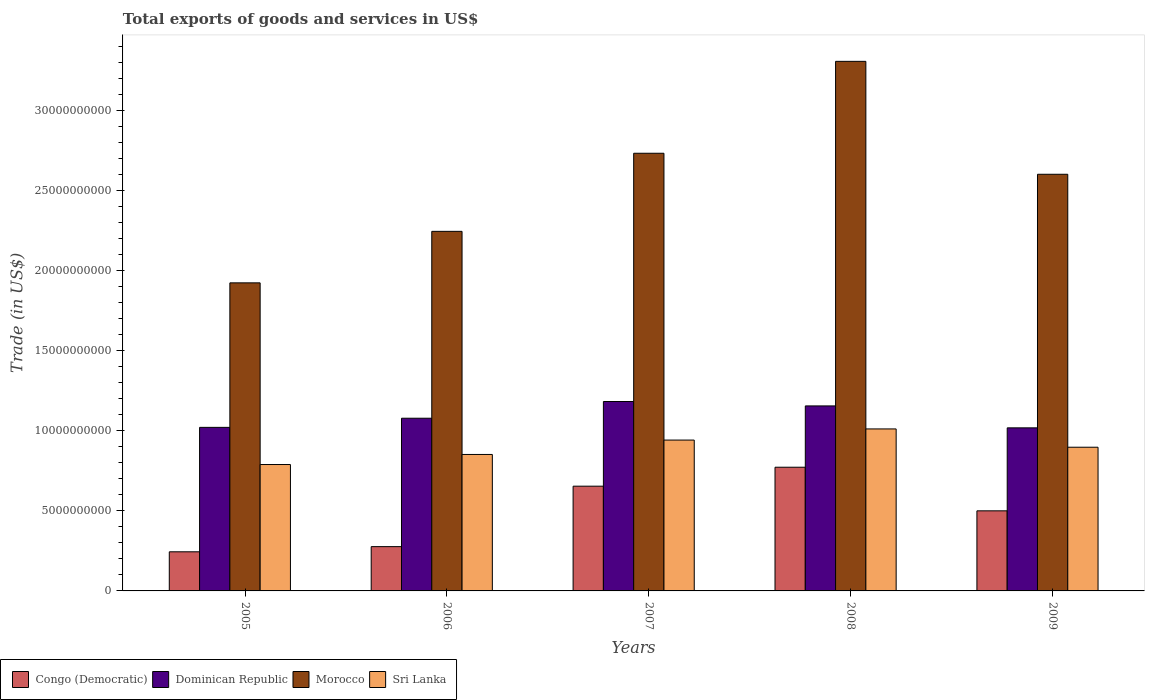Are the number of bars on each tick of the X-axis equal?
Offer a very short reply. Yes. What is the total exports of goods and services in Sri Lanka in 2009?
Offer a terse response. 8.97e+09. Across all years, what is the maximum total exports of goods and services in Dominican Republic?
Offer a very short reply. 1.18e+1. Across all years, what is the minimum total exports of goods and services in Dominican Republic?
Offer a terse response. 1.02e+1. In which year was the total exports of goods and services in Dominican Republic maximum?
Make the answer very short. 2007. What is the total total exports of goods and services in Congo (Democratic) in the graph?
Your answer should be compact. 2.45e+1. What is the difference between the total exports of goods and services in Sri Lanka in 2007 and that in 2009?
Provide a short and direct response. 4.47e+08. What is the difference between the total exports of goods and services in Sri Lanka in 2008 and the total exports of goods and services in Dominican Republic in 2007?
Your answer should be very brief. -1.71e+09. What is the average total exports of goods and services in Dominican Republic per year?
Your response must be concise. 1.09e+1. In the year 2006, what is the difference between the total exports of goods and services in Dominican Republic and total exports of goods and services in Congo (Democratic)?
Keep it short and to the point. 8.02e+09. In how many years, is the total exports of goods and services in Sri Lanka greater than 2000000000 US$?
Your answer should be compact. 5. What is the ratio of the total exports of goods and services in Morocco in 2006 to that in 2009?
Offer a very short reply. 0.86. Is the total exports of goods and services in Sri Lanka in 2005 less than that in 2007?
Your response must be concise. Yes. Is the difference between the total exports of goods and services in Dominican Republic in 2006 and 2008 greater than the difference between the total exports of goods and services in Congo (Democratic) in 2006 and 2008?
Keep it short and to the point. Yes. What is the difference between the highest and the second highest total exports of goods and services in Morocco?
Your answer should be very brief. 5.74e+09. What is the difference between the highest and the lowest total exports of goods and services in Sri Lanka?
Provide a short and direct response. 2.22e+09. Is it the case that in every year, the sum of the total exports of goods and services in Morocco and total exports of goods and services in Sri Lanka is greater than the sum of total exports of goods and services in Dominican Republic and total exports of goods and services in Congo (Democratic)?
Make the answer very short. Yes. What does the 2nd bar from the left in 2007 represents?
Offer a very short reply. Dominican Republic. What does the 1st bar from the right in 2008 represents?
Provide a short and direct response. Sri Lanka. What is the difference between two consecutive major ticks on the Y-axis?
Ensure brevity in your answer.  5.00e+09. Are the values on the major ticks of Y-axis written in scientific E-notation?
Provide a short and direct response. No. Does the graph contain any zero values?
Make the answer very short. No. Where does the legend appear in the graph?
Provide a succinct answer. Bottom left. How many legend labels are there?
Your response must be concise. 4. How are the legend labels stacked?
Provide a short and direct response. Horizontal. What is the title of the graph?
Provide a short and direct response. Total exports of goods and services in US$. Does "Micronesia" appear as one of the legend labels in the graph?
Your response must be concise. No. What is the label or title of the Y-axis?
Ensure brevity in your answer.  Trade (in US$). What is the Trade (in US$) of Congo (Democratic) in 2005?
Give a very brief answer. 2.44e+09. What is the Trade (in US$) in Dominican Republic in 2005?
Keep it short and to the point. 1.02e+1. What is the Trade (in US$) in Morocco in 2005?
Give a very brief answer. 1.92e+1. What is the Trade (in US$) in Sri Lanka in 2005?
Make the answer very short. 7.89e+09. What is the Trade (in US$) in Congo (Democratic) in 2006?
Keep it short and to the point. 2.77e+09. What is the Trade (in US$) of Dominican Republic in 2006?
Offer a very short reply. 1.08e+1. What is the Trade (in US$) of Morocco in 2006?
Your answer should be very brief. 2.24e+1. What is the Trade (in US$) of Sri Lanka in 2006?
Your response must be concise. 8.52e+09. What is the Trade (in US$) in Congo (Democratic) in 2007?
Make the answer very short. 6.54e+09. What is the Trade (in US$) of Dominican Republic in 2007?
Your response must be concise. 1.18e+1. What is the Trade (in US$) in Morocco in 2007?
Provide a short and direct response. 2.73e+1. What is the Trade (in US$) in Sri Lanka in 2007?
Make the answer very short. 9.42e+09. What is the Trade (in US$) of Congo (Democratic) in 2008?
Ensure brevity in your answer.  7.72e+09. What is the Trade (in US$) in Dominican Republic in 2008?
Your answer should be compact. 1.16e+1. What is the Trade (in US$) in Morocco in 2008?
Give a very brief answer. 3.31e+1. What is the Trade (in US$) of Sri Lanka in 2008?
Offer a terse response. 1.01e+1. What is the Trade (in US$) in Congo (Democratic) in 2009?
Ensure brevity in your answer.  5.00e+09. What is the Trade (in US$) in Dominican Republic in 2009?
Make the answer very short. 1.02e+1. What is the Trade (in US$) in Morocco in 2009?
Provide a succinct answer. 2.60e+1. What is the Trade (in US$) in Sri Lanka in 2009?
Provide a succinct answer. 8.97e+09. Across all years, what is the maximum Trade (in US$) in Congo (Democratic)?
Ensure brevity in your answer.  7.72e+09. Across all years, what is the maximum Trade (in US$) of Dominican Republic?
Provide a succinct answer. 1.18e+1. Across all years, what is the maximum Trade (in US$) of Morocco?
Your answer should be very brief. 3.31e+1. Across all years, what is the maximum Trade (in US$) of Sri Lanka?
Your answer should be very brief. 1.01e+1. Across all years, what is the minimum Trade (in US$) of Congo (Democratic)?
Your answer should be compact. 2.44e+09. Across all years, what is the minimum Trade (in US$) in Dominican Republic?
Make the answer very short. 1.02e+1. Across all years, what is the minimum Trade (in US$) in Morocco?
Your answer should be compact. 1.92e+1. Across all years, what is the minimum Trade (in US$) of Sri Lanka?
Offer a terse response. 7.89e+09. What is the total Trade (in US$) of Congo (Democratic) in the graph?
Provide a succinct answer. 2.45e+1. What is the total Trade (in US$) of Dominican Republic in the graph?
Your response must be concise. 5.46e+1. What is the total Trade (in US$) of Morocco in the graph?
Your response must be concise. 1.28e+11. What is the total Trade (in US$) in Sri Lanka in the graph?
Keep it short and to the point. 4.49e+1. What is the difference between the Trade (in US$) of Congo (Democratic) in 2005 and that in 2006?
Your answer should be compact. -3.23e+08. What is the difference between the Trade (in US$) in Dominican Republic in 2005 and that in 2006?
Your response must be concise. -5.71e+08. What is the difference between the Trade (in US$) in Morocco in 2005 and that in 2006?
Keep it short and to the point. -3.22e+09. What is the difference between the Trade (in US$) in Sri Lanka in 2005 and that in 2006?
Offer a terse response. -6.28e+08. What is the difference between the Trade (in US$) in Congo (Democratic) in 2005 and that in 2007?
Keep it short and to the point. -4.10e+09. What is the difference between the Trade (in US$) of Dominican Republic in 2005 and that in 2007?
Offer a very short reply. -1.61e+09. What is the difference between the Trade (in US$) in Morocco in 2005 and that in 2007?
Provide a succinct answer. -8.09e+09. What is the difference between the Trade (in US$) in Sri Lanka in 2005 and that in 2007?
Make the answer very short. -1.53e+09. What is the difference between the Trade (in US$) of Congo (Democratic) in 2005 and that in 2008?
Your response must be concise. -5.28e+09. What is the difference between the Trade (in US$) of Dominican Republic in 2005 and that in 2008?
Make the answer very short. -1.34e+09. What is the difference between the Trade (in US$) of Morocco in 2005 and that in 2008?
Offer a terse response. -1.38e+1. What is the difference between the Trade (in US$) of Sri Lanka in 2005 and that in 2008?
Keep it short and to the point. -2.22e+09. What is the difference between the Trade (in US$) of Congo (Democratic) in 2005 and that in 2009?
Your response must be concise. -2.56e+09. What is the difference between the Trade (in US$) in Dominican Republic in 2005 and that in 2009?
Make the answer very short. 2.99e+07. What is the difference between the Trade (in US$) in Morocco in 2005 and that in 2009?
Make the answer very short. -6.78e+09. What is the difference between the Trade (in US$) of Sri Lanka in 2005 and that in 2009?
Keep it short and to the point. -1.08e+09. What is the difference between the Trade (in US$) in Congo (Democratic) in 2006 and that in 2007?
Provide a succinct answer. -3.77e+09. What is the difference between the Trade (in US$) of Dominican Republic in 2006 and that in 2007?
Your response must be concise. -1.04e+09. What is the difference between the Trade (in US$) of Morocco in 2006 and that in 2007?
Provide a short and direct response. -4.88e+09. What is the difference between the Trade (in US$) of Sri Lanka in 2006 and that in 2007?
Your answer should be compact. -8.98e+08. What is the difference between the Trade (in US$) in Congo (Democratic) in 2006 and that in 2008?
Make the answer very short. -4.96e+09. What is the difference between the Trade (in US$) in Dominican Republic in 2006 and that in 2008?
Your answer should be very brief. -7.68e+08. What is the difference between the Trade (in US$) of Morocco in 2006 and that in 2008?
Offer a very short reply. -1.06e+1. What is the difference between the Trade (in US$) in Sri Lanka in 2006 and that in 2008?
Your answer should be very brief. -1.59e+09. What is the difference between the Trade (in US$) in Congo (Democratic) in 2006 and that in 2009?
Provide a short and direct response. -2.24e+09. What is the difference between the Trade (in US$) of Dominican Republic in 2006 and that in 2009?
Provide a succinct answer. 6.01e+08. What is the difference between the Trade (in US$) in Morocco in 2006 and that in 2009?
Your answer should be compact. -3.56e+09. What is the difference between the Trade (in US$) of Sri Lanka in 2006 and that in 2009?
Give a very brief answer. -4.52e+08. What is the difference between the Trade (in US$) in Congo (Democratic) in 2007 and that in 2008?
Ensure brevity in your answer.  -1.18e+09. What is the difference between the Trade (in US$) of Dominican Republic in 2007 and that in 2008?
Your answer should be very brief. 2.75e+08. What is the difference between the Trade (in US$) in Morocco in 2007 and that in 2008?
Keep it short and to the point. -5.74e+09. What is the difference between the Trade (in US$) of Sri Lanka in 2007 and that in 2008?
Offer a terse response. -6.95e+08. What is the difference between the Trade (in US$) of Congo (Democratic) in 2007 and that in 2009?
Keep it short and to the point. 1.54e+09. What is the difference between the Trade (in US$) of Dominican Republic in 2007 and that in 2009?
Give a very brief answer. 1.64e+09. What is the difference between the Trade (in US$) in Morocco in 2007 and that in 2009?
Your response must be concise. 1.31e+09. What is the difference between the Trade (in US$) of Sri Lanka in 2007 and that in 2009?
Make the answer very short. 4.47e+08. What is the difference between the Trade (in US$) in Congo (Democratic) in 2008 and that in 2009?
Ensure brevity in your answer.  2.72e+09. What is the difference between the Trade (in US$) of Dominican Republic in 2008 and that in 2009?
Your answer should be compact. 1.37e+09. What is the difference between the Trade (in US$) in Morocco in 2008 and that in 2009?
Your response must be concise. 7.05e+09. What is the difference between the Trade (in US$) of Sri Lanka in 2008 and that in 2009?
Your answer should be very brief. 1.14e+09. What is the difference between the Trade (in US$) in Congo (Democratic) in 2005 and the Trade (in US$) in Dominican Republic in 2006?
Your response must be concise. -8.34e+09. What is the difference between the Trade (in US$) in Congo (Democratic) in 2005 and the Trade (in US$) in Morocco in 2006?
Make the answer very short. -2.00e+1. What is the difference between the Trade (in US$) in Congo (Democratic) in 2005 and the Trade (in US$) in Sri Lanka in 2006?
Provide a short and direct response. -6.08e+09. What is the difference between the Trade (in US$) of Dominican Republic in 2005 and the Trade (in US$) of Morocco in 2006?
Give a very brief answer. -1.22e+1. What is the difference between the Trade (in US$) in Dominican Republic in 2005 and the Trade (in US$) in Sri Lanka in 2006?
Provide a short and direct response. 1.69e+09. What is the difference between the Trade (in US$) in Morocco in 2005 and the Trade (in US$) in Sri Lanka in 2006?
Provide a short and direct response. 1.07e+1. What is the difference between the Trade (in US$) of Congo (Democratic) in 2005 and the Trade (in US$) of Dominican Republic in 2007?
Your answer should be very brief. -9.38e+09. What is the difference between the Trade (in US$) in Congo (Democratic) in 2005 and the Trade (in US$) in Morocco in 2007?
Make the answer very short. -2.49e+1. What is the difference between the Trade (in US$) of Congo (Democratic) in 2005 and the Trade (in US$) of Sri Lanka in 2007?
Your answer should be very brief. -6.98e+09. What is the difference between the Trade (in US$) of Dominican Republic in 2005 and the Trade (in US$) of Morocco in 2007?
Provide a succinct answer. -1.71e+1. What is the difference between the Trade (in US$) in Dominican Republic in 2005 and the Trade (in US$) in Sri Lanka in 2007?
Ensure brevity in your answer.  7.93e+08. What is the difference between the Trade (in US$) of Morocco in 2005 and the Trade (in US$) of Sri Lanka in 2007?
Provide a succinct answer. 9.82e+09. What is the difference between the Trade (in US$) in Congo (Democratic) in 2005 and the Trade (in US$) in Dominican Republic in 2008?
Your answer should be compact. -9.11e+09. What is the difference between the Trade (in US$) of Congo (Democratic) in 2005 and the Trade (in US$) of Morocco in 2008?
Your response must be concise. -3.06e+1. What is the difference between the Trade (in US$) in Congo (Democratic) in 2005 and the Trade (in US$) in Sri Lanka in 2008?
Keep it short and to the point. -7.67e+09. What is the difference between the Trade (in US$) of Dominican Republic in 2005 and the Trade (in US$) of Morocco in 2008?
Ensure brevity in your answer.  -2.29e+1. What is the difference between the Trade (in US$) of Dominican Republic in 2005 and the Trade (in US$) of Sri Lanka in 2008?
Make the answer very short. 9.77e+07. What is the difference between the Trade (in US$) of Morocco in 2005 and the Trade (in US$) of Sri Lanka in 2008?
Make the answer very short. 9.12e+09. What is the difference between the Trade (in US$) in Congo (Democratic) in 2005 and the Trade (in US$) in Dominican Republic in 2009?
Your answer should be very brief. -7.74e+09. What is the difference between the Trade (in US$) in Congo (Democratic) in 2005 and the Trade (in US$) in Morocco in 2009?
Give a very brief answer. -2.36e+1. What is the difference between the Trade (in US$) of Congo (Democratic) in 2005 and the Trade (in US$) of Sri Lanka in 2009?
Give a very brief answer. -6.53e+09. What is the difference between the Trade (in US$) in Dominican Republic in 2005 and the Trade (in US$) in Morocco in 2009?
Offer a very short reply. -1.58e+1. What is the difference between the Trade (in US$) in Dominican Republic in 2005 and the Trade (in US$) in Sri Lanka in 2009?
Give a very brief answer. 1.24e+09. What is the difference between the Trade (in US$) of Morocco in 2005 and the Trade (in US$) of Sri Lanka in 2009?
Offer a very short reply. 1.03e+1. What is the difference between the Trade (in US$) of Congo (Democratic) in 2006 and the Trade (in US$) of Dominican Republic in 2007?
Ensure brevity in your answer.  -9.06e+09. What is the difference between the Trade (in US$) in Congo (Democratic) in 2006 and the Trade (in US$) in Morocco in 2007?
Offer a very short reply. -2.46e+1. What is the difference between the Trade (in US$) of Congo (Democratic) in 2006 and the Trade (in US$) of Sri Lanka in 2007?
Offer a terse response. -6.65e+09. What is the difference between the Trade (in US$) in Dominican Republic in 2006 and the Trade (in US$) in Morocco in 2007?
Your answer should be very brief. -1.65e+1. What is the difference between the Trade (in US$) in Dominican Republic in 2006 and the Trade (in US$) in Sri Lanka in 2007?
Provide a short and direct response. 1.36e+09. What is the difference between the Trade (in US$) of Morocco in 2006 and the Trade (in US$) of Sri Lanka in 2007?
Provide a short and direct response. 1.30e+1. What is the difference between the Trade (in US$) of Congo (Democratic) in 2006 and the Trade (in US$) of Dominican Republic in 2008?
Offer a terse response. -8.79e+09. What is the difference between the Trade (in US$) of Congo (Democratic) in 2006 and the Trade (in US$) of Morocco in 2008?
Give a very brief answer. -3.03e+1. What is the difference between the Trade (in US$) of Congo (Democratic) in 2006 and the Trade (in US$) of Sri Lanka in 2008?
Provide a succinct answer. -7.35e+09. What is the difference between the Trade (in US$) of Dominican Republic in 2006 and the Trade (in US$) of Morocco in 2008?
Offer a terse response. -2.23e+1. What is the difference between the Trade (in US$) of Dominican Republic in 2006 and the Trade (in US$) of Sri Lanka in 2008?
Your answer should be very brief. 6.69e+08. What is the difference between the Trade (in US$) of Morocco in 2006 and the Trade (in US$) of Sri Lanka in 2008?
Ensure brevity in your answer.  1.23e+1. What is the difference between the Trade (in US$) in Congo (Democratic) in 2006 and the Trade (in US$) in Dominican Republic in 2009?
Ensure brevity in your answer.  -7.42e+09. What is the difference between the Trade (in US$) of Congo (Democratic) in 2006 and the Trade (in US$) of Morocco in 2009?
Give a very brief answer. -2.32e+1. What is the difference between the Trade (in US$) of Congo (Democratic) in 2006 and the Trade (in US$) of Sri Lanka in 2009?
Make the answer very short. -6.21e+09. What is the difference between the Trade (in US$) in Dominican Republic in 2006 and the Trade (in US$) in Morocco in 2009?
Offer a very short reply. -1.52e+1. What is the difference between the Trade (in US$) in Dominican Republic in 2006 and the Trade (in US$) in Sri Lanka in 2009?
Offer a terse response. 1.81e+09. What is the difference between the Trade (in US$) of Morocco in 2006 and the Trade (in US$) of Sri Lanka in 2009?
Your answer should be compact. 1.35e+1. What is the difference between the Trade (in US$) in Congo (Democratic) in 2007 and the Trade (in US$) in Dominican Republic in 2008?
Offer a terse response. -5.01e+09. What is the difference between the Trade (in US$) of Congo (Democratic) in 2007 and the Trade (in US$) of Morocco in 2008?
Offer a terse response. -2.65e+1. What is the difference between the Trade (in US$) in Congo (Democratic) in 2007 and the Trade (in US$) in Sri Lanka in 2008?
Offer a very short reply. -3.57e+09. What is the difference between the Trade (in US$) of Dominican Republic in 2007 and the Trade (in US$) of Morocco in 2008?
Provide a short and direct response. -2.12e+1. What is the difference between the Trade (in US$) of Dominican Republic in 2007 and the Trade (in US$) of Sri Lanka in 2008?
Offer a very short reply. 1.71e+09. What is the difference between the Trade (in US$) in Morocco in 2007 and the Trade (in US$) in Sri Lanka in 2008?
Ensure brevity in your answer.  1.72e+1. What is the difference between the Trade (in US$) in Congo (Democratic) in 2007 and the Trade (in US$) in Dominican Republic in 2009?
Your response must be concise. -3.64e+09. What is the difference between the Trade (in US$) of Congo (Democratic) in 2007 and the Trade (in US$) of Morocco in 2009?
Your answer should be very brief. -1.95e+1. What is the difference between the Trade (in US$) of Congo (Democratic) in 2007 and the Trade (in US$) of Sri Lanka in 2009?
Offer a very short reply. -2.43e+09. What is the difference between the Trade (in US$) of Dominican Republic in 2007 and the Trade (in US$) of Morocco in 2009?
Your response must be concise. -1.42e+1. What is the difference between the Trade (in US$) in Dominican Republic in 2007 and the Trade (in US$) in Sri Lanka in 2009?
Your answer should be very brief. 2.85e+09. What is the difference between the Trade (in US$) in Morocco in 2007 and the Trade (in US$) in Sri Lanka in 2009?
Keep it short and to the point. 1.84e+1. What is the difference between the Trade (in US$) of Congo (Democratic) in 2008 and the Trade (in US$) of Dominican Republic in 2009?
Ensure brevity in your answer.  -2.46e+09. What is the difference between the Trade (in US$) of Congo (Democratic) in 2008 and the Trade (in US$) of Morocco in 2009?
Your response must be concise. -1.83e+1. What is the difference between the Trade (in US$) in Congo (Democratic) in 2008 and the Trade (in US$) in Sri Lanka in 2009?
Keep it short and to the point. -1.25e+09. What is the difference between the Trade (in US$) of Dominican Republic in 2008 and the Trade (in US$) of Morocco in 2009?
Keep it short and to the point. -1.45e+1. What is the difference between the Trade (in US$) in Dominican Republic in 2008 and the Trade (in US$) in Sri Lanka in 2009?
Ensure brevity in your answer.  2.58e+09. What is the difference between the Trade (in US$) in Morocco in 2008 and the Trade (in US$) in Sri Lanka in 2009?
Your response must be concise. 2.41e+1. What is the average Trade (in US$) in Congo (Democratic) per year?
Give a very brief answer. 4.89e+09. What is the average Trade (in US$) of Dominican Republic per year?
Your answer should be compact. 1.09e+1. What is the average Trade (in US$) of Morocco per year?
Your response must be concise. 2.56e+1. What is the average Trade (in US$) of Sri Lanka per year?
Provide a short and direct response. 8.98e+09. In the year 2005, what is the difference between the Trade (in US$) of Congo (Democratic) and Trade (in US$) of Dominican Republic?
Your response must be concise. -7.77e+09. In the year 2005, what is the difference between the Trade (in US$) in Congo (Democratic) and Trade (in US$) in Morocco?
Your answer should be very brief. -1.68e+1. In the year 2005, what is the difference between the Trade (in US$) in Congo (Democratic) and Trade (in US$) in Sri Lanka?
Keep it short and to the point. -5.45e+09. In the year 2005, what is the difference between the Trade (in US$) of Dominican Republic and Trade (in US$) of Morocco?
Your response must be concise. -9.02e+09. In the year 2005, what is the difference between the Trade (in US$) of Dominican Republic and Trade (in US$) of Sri Lanka?
Keep it short and to the point. 2.32e+09. In the year 2005, what is the difference between the Trade (in US$) in Morocco and Trade (in US$) in Sri Lanka?
Your response must be concise. 1.13e+1. In the year 2006, what is the difference between the Trade (in US$) of Congo (Democratic) and Trade (in US$) of Dominican Republic?
Offer a very short reply. -8.02e+09. In the year 2006, what is the difference between the Trade (in US$) in Congo (Democratic) and Trade (in US$) in Morocco?
Ensure brevity in your answer.  -1.97e+1. In the year 2006, what is the difference between the Trade (in US$) of Congo (Democratic) and Trade (in US$) of Sri Lanka?
Make the answer very short. -5.76e+09. In the year 2006, what is the difference between the Trade (in US$) in Dominican Republic and Trade (in US$) in Morocco?
Your answer should be very brief. -1.17e+1. In the year 2006, what is the difference between the Trade (in US$) in Dominican Republic and Trade (in US$) in Sri Lanka?
Keep it short and to the point. 2.26e+09. In the year 2006, what is the difference between the Trade (in US$) in Morocco and Trade (in US$) in Sri Lanka?
Provide a short and direct response. 1.39e+1. In the year 2007, what is the difference between the Trade (in US$) of Congo (Democratic) and Trade (in US$) of Dominican Republic?
Offer a very short reply. -5.29e+09. In the year 2007, what is the difference between the Trade (in US$) in Congo (Democratic) and Trade (in US$) in Morocco?
Keep it short and to the point. -2.08e+1. In the year 2007, what is the difference between the Trade (in US$) of Congo (Democratic) and Trade (in US$) of Sri Lanka?
Provide a short and direct response. -2.88e+09. In the year 2007, what is the difference between the Trade (in US$) in Dominican Republic and Trade (in US$) in Morocco?
Keep it short and to the point. -1.55e+1. In the year 2007, what is the difference between the Trade (in US$) of Dominican Republic and Trade (in US$) of Sri Lanka?
Make the answer very short. 2.41e+09. In the year 2007, what is the difference between the Trade (in US$) of Morocco and Trade (in US$) of Sri Lanka?
Offer a terse response. 1.79e+1. In the year 2008, what is the difference between the Trade (in US$) of Congo (Democratic) and Trade (in US$) of Dominican Republic?
Offer a terse response. -3.83e+09. In the year 2008, what is the difference between the Trade (in US$) in Congo (Democratic) and Trade (in US$) in Morocco?
Give a very brief answer. -2.53e+1. In the year 2008, what is the difference between the Trade (in US$) of Congo (Democratic) and Trade (in US$) of Sri Lanka?
Your answer should be very brief. -2.39e+09. In the year 2008, what is the difference between the Trade (in US$) of Dominican Republic and Trade (in US$) of Morocco?
Provide a short and direct response. -2.15e+1. In the year 2008, what is the difference between the Trade (in US$) of Dominican Republic and Trade (in US$) of Sri Lanka?
Provide a succinct answer. 1.44e+09. In the year 2008, what is the difference between the Trade (in US$) in Morocco and Trade (in US$) in Sri Lanka?
Ensure brevity in your answer.  2.30e+1. In the year 2009, what is the difference between the Trade (in US$) in Congo (Democratic) and Trade (in US$) in Dominican Republic?
Provide a short and direct response. -5.18e+09. In the year 2009, what is the difference between the Trade (in US$) of Congo (Democratic) and Trade (in US$) of Morocco?
Your response must be concise. -2.10e+1. In the year 2009, what is the difference between the Trade (in US$) of Congo (Democratic) and Trade (in US$) of Sri Lanka?
Provide a short and direct response. -3.97e+09. In the year 2009, what is the difference between the Trade (in US$) in Dominican Republic and Trade (in US$) in Morocco?
Give a very brief answer. -1.58e+1. In the year 2009, what is the difference between the Trade (in US$) in Dominican Republic and Trade (in US$) in Sri Lanka?
Ensure brevity in your answer.  1.21e+09. In the year 2009, what is the difference between the Trade (in US$) of Morocco and Trade (in US$) of Sri Lanka?
Your response must be concise. 1.70e+1. What is the ratio of the Trade (in US$) of Congo (Democratic) in 2005 to that in 2006?
Keep it short and to the point. 0.88. What is the ratio of the Trade (in US$) in Dominican Republic in 2005 to that in 2006?
Your response must be concise. 0.95. What is the ratio of the Trade (in US$) of Morocco in 2005 to that in 2006?
Make the answer very short. 0.86. What is the ratio of the Trade (in US$) of Sri Lanka in 2005 to that in 2006?
Provide a succinct answer. 0.93. What is the ratio of the Trade (in US$) of Congo (Democratic) in 2005 to that in 2007?
Offer a very short reply. 0.37. What is the ratio of the Trade (in US$) in Dominican Republic in 2005 to that in 2007?
Your answer should be very brief. 0.86. What is the ratio of the Trade (in US$) in Morocco in 2005 to that in 2007?
Provide a short and direct response. 0.7. What is the ratio of the Trade (in US$) in Sri Lanka in 2005 to that in 2007?
Offer a very short reply. 0.84. What is the ratio of the Trade (in US$) in Congo (Democratic) in 2005 to that in 2008?
Your answer should be compact. 0.32. What is the ratio of the Trade (in US$) of Dominican Republic in 2005 to that in 2008?
Offer a terse response. 0.88. What is the ratio of the Trade (in US$) in Morocco in 2005 to that in 2008?
Your answer should be very brief. 0.58. What is the ratio of the Trade (in US$) of Sri Lanka in 2005 to that in 2008?
Offer a very short reply. 0.78. What is the ratio of the Trade (in US$) in Congo (Democratic) in 2005 to that in 2009?
Your answer should be compact. 0.49. What is the ratio of the Trade (in US$) of Morocco in 2005 to that in 2009?
Your response must be concise. 0.74. What is the ratio of the Trade (in US$) of Sri Lanka in 2005 to that in 2009?
Give a very brief answer. 0.88. What is the ratio of the Trade (in US$) of Congo (Democratic) in 2006 to that in 2007?
Make the answer very short. 0.42. What is the ratio of the Trade (in US$) of Dominican Republic in 2006 to that in 2007?
Provide a short and direct response. 0.91. What is the ratio of the Trade (in US$) of Morocco in 2006 to that in 2007?
Offer a terse response. 0.82. What is the ratio of the Trade (in US$) in Sri Lanka in 2006 to that in 2007?
Ensure brevity in your answer.  0.9. What is the ratio of the Trade (in US$) of Congo (Democratic) in 2006 to that in 2008?
Provide a short and direct response. 0.36. What is the ratio of the Trade (in US$) in Dominican Republic in 2006 to that in 2008?
Your answer should be compact. 0.93. What is the ratio of the Trade (in US$) of Morocco in 2006 to that in 2008?
Your answer should be compact. 0.68. What is the ratio of the Trade (in US$) of Sri Lanka in 2006 to that in 2008?
Keep it short and to the point. 0.84. What is the ratio of the Trade (in US$) of Congo (Democratic) in 2006 to that in 2009?
Make the answer very short. 0.55. What is the ratio of the Trade (in US$) of Dominican Republic in 2006 to that in 2009?
Offer a terse response. 1.06. What is the ratio of the Trade (in US$) in Morocco in 2006 to that in 2009?
Offer a terse response. 0.86. What is the ratio of the Trade (in US$) in Sri Lanka in 2006 to that in 2009?
Offer a terse response. 0.95. What is the ratio of the Trade (in US$) in Congo (Democratic) in 2007 to that in 2008?
Provide a short and direct response. 0.85. What is the ratio of the Trade (in US$) in Dominican Republic in 2007 to that in 2008?
Provide a short and direct response. 1.02. What is the ratio of the Trade (in US$) of Morocco in 2007 to that in 2008?
Ensure brevity in your answer.  0.83. What is the ratio of the Trade (in US$) in Sri Lanka in 2007 to that in 2008?
Keep it short and to the point. 0.93. What is the ratio of the Trade (in US$) in Congo (Democratic) in 2007 to that in 2009?
Provide a short and direct response. 1.31. What is the ratio of the Trade (in US$) in Dominican Republic in 2007 to that in 2009?
Offer a very short reply. 1.16. What is the ratio of the Trade (in US$) of Morocco in 2007 to that in 2009?
Provide a succinct answer. 1.05. What is the ratio of the Trade (in US$) in Sri Lanka in 2007 to that in 2009?
Ensure brevity in your answer.  1.05. What is the ratio of the Trade (in US$) of Congo (Democratic) in 2008 to that in 2009?
Offer a very short reply. 1.54. What is the ratio of the Trade (in US$) of Dominican Republic in 2008 to that in 2009?
Offer a very short reply. 1.13. What is the ratio of the Trade (in US$) of Morocco in 2008 to that in 2009?
Keep it short and to the point. 1.27. What is the ratio of the Trade (in US$) of Sri Lanka in 2008 to that in 2009?
Ensure brevity in your answer.  1.13. What is the difference between the highest and the second highest Trade (in US$) in Congo (Democratic)?
Ensure brevity in your answer.  1.18e+09. What is the difference between the highest and the second highest Trade (in US$) in Dominican Republic?
Provide a short and direct response. 2.75e+08. What is the difference between the highest and the second highest Trade (in US$) in Morocco?
Keep it short and to the point. 5.74e+09. What is the difference between the highest and the second highest Trade (in US$) of Sri Lanka?
Provide a short and direct response. 6.95e+08. What is the difference between the highest and the lowest Trade (in US$) of Congo (Democratic)?
Give a very brief answer. 5.28e+09. What is the difference between the highest and the lowest Trade (in US$) of Dominican Republic?
Provide a succinct answer. 1.64e+09. What is the difference between the highest and the lowest Trade (in US$) in Morocco?
Provide a short and direct response. 1.38e+1. What is the difference between the highest and the lowest Trade (in US$) in Sri Lanka?
Make the answer very short. 2.22e+09. 